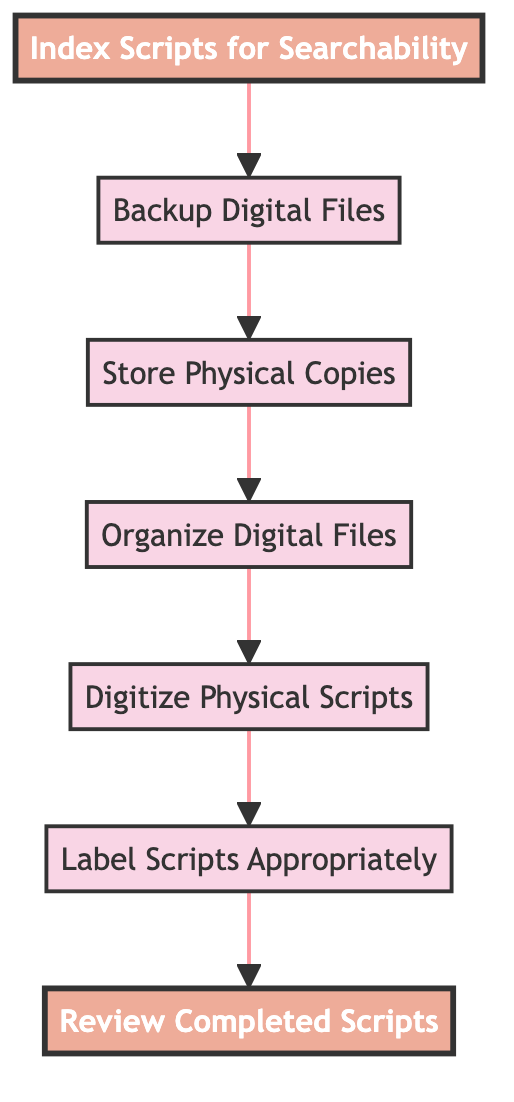What is the top node in the diagram? The top node is the starting point in the flow, which is the "Review Completed Scripts" step.
Answer: Review Completed Scripts How many nodes are there in total? Counting each unique step in the flow, there are seven distinct nodes represented in the diagram.
Answer: 7 Which step comes immediately before "Backup Digital Files"? The step that comes directly before "Backup Digital Files" is "Index Scripts for Searchability."
Answer: Index Scripts for Searchability What is the last step in the process? The last step, or bottom node in the flow, is "Review Completed Scripts," which is the final action taken after all preceding steps.
Answer: Review Completed Scripts Which step follows "Organize Digital Files"? The action that takes place right after "Organize Digital Files" is "Store Physical Copies."
Answer: Store Physical Copies Which two steps are highlighted in the diagram? The highlighted steps in the diagram are "Review Completed Scripts" and "Index Scripts for Searchability."
Answer: Review Completed Scripts, Index Scripts for Searchability What is required before organizing digital files? Before organizing digital files, you must digitize the physical scripts.
Answer: Digitize Physical Scripts What is the relationship between "Backup Digital Files" and "Store Physical Copies"? "Backup Digital Files" follows "Store Physical Copies" in the sequence of actions, indicating that these steps are sequentially linked in the archiving process.
Answer: Sequential relationship 